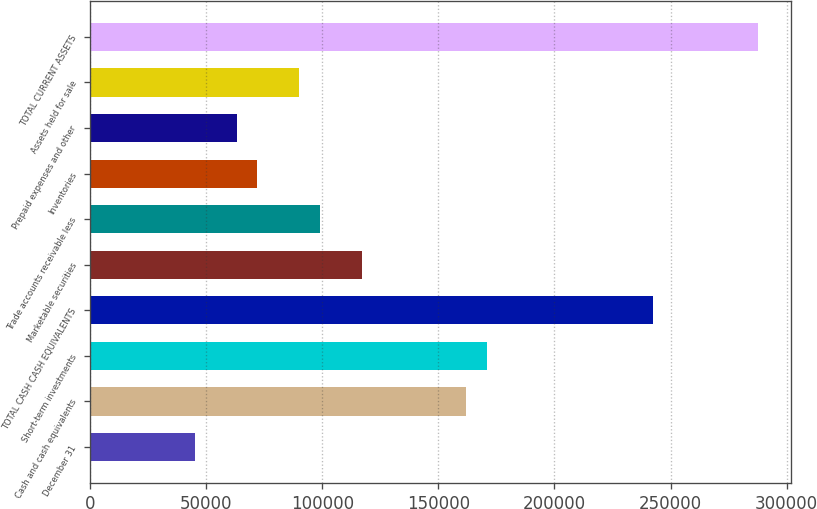Convert chart. <chart><loc_0><loc_0><loc_500><loc_500><bar_chart><fcel>December 31<fcel>Cash and cash equivalents<fcel>Short-term investments<fcel>TOTAL CASH CASH EQUIVALENTS<fcel>Marketable securities<fcel>Trade accounts receivable less<fcel>Inventories<fcel>Prepaid expenses and other<fcel>Assets held for sale<fcel>TOTAL CURRENT ASSETS<nl><fcel>45103<fcel>161825<fcel>170803<fcel>242632<fcel>116932<fcel>98974.6<fcel>72038.8<fcel>63060.2<fcel>89996<fcel>287525<nl></chart> 